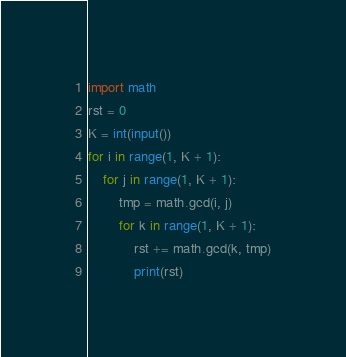Convert code to text. <code><loc_0><loc_0><loc_500><loc_500><_Python_>

import math
rst = 0
K = int(input())
for i in range(1, K + 1):
    for j in range(1, K + 1):
        tmp = math.gcd(i, j)
        for k in range(1, K + 1):
            rst += math.gcd(k, tmp)
            print(rst)
</code> 